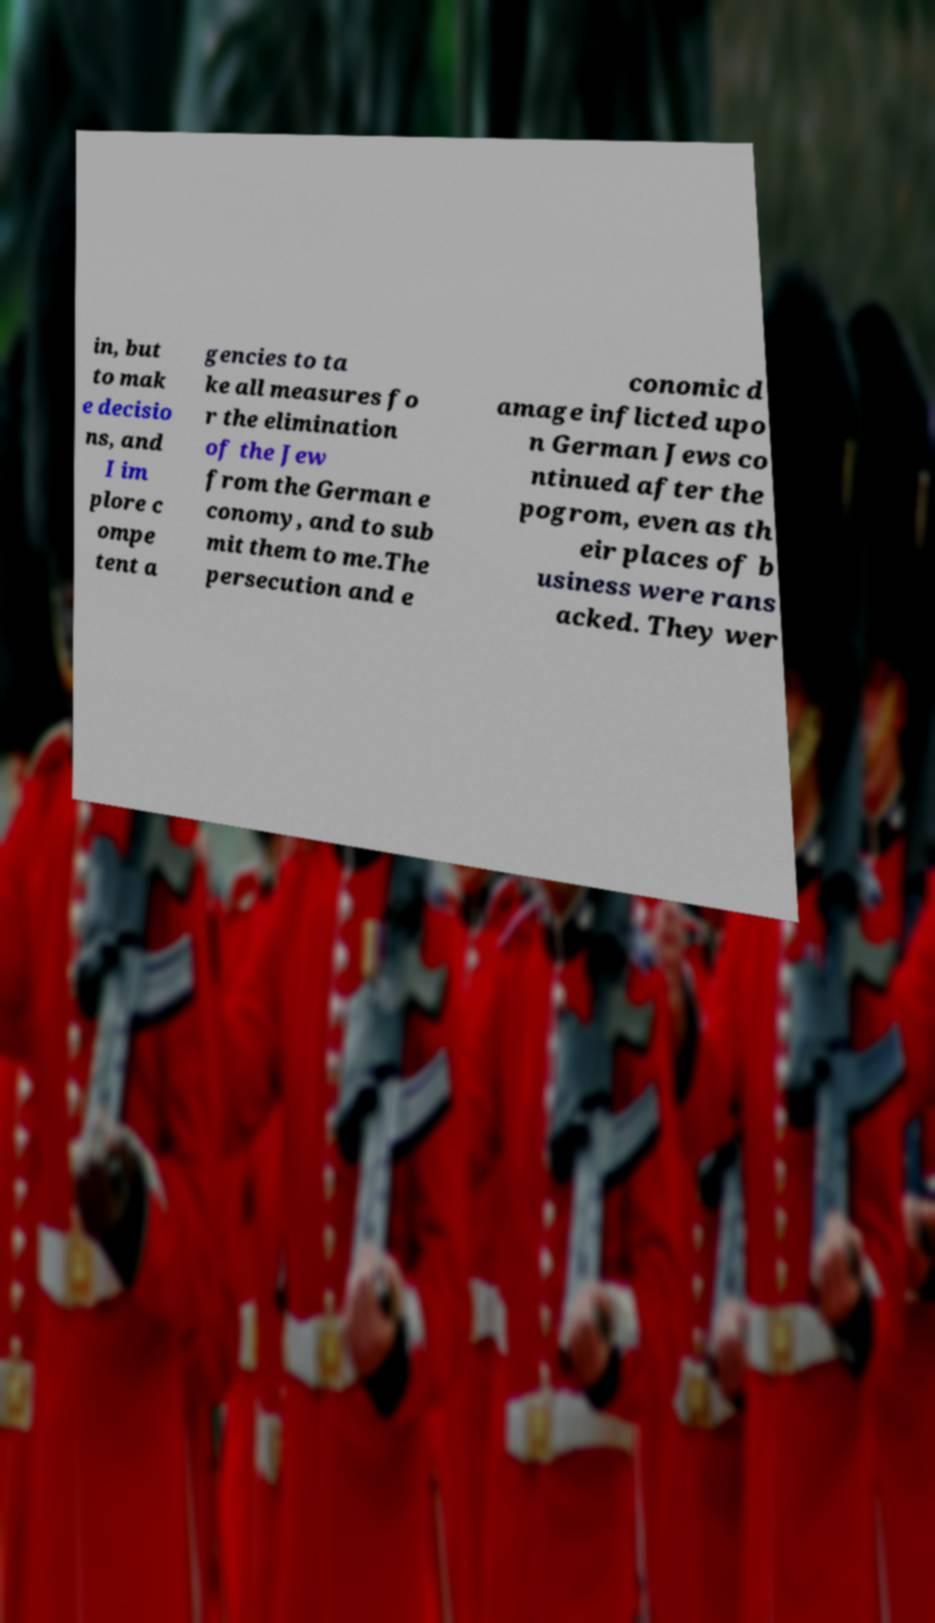I need the written content from this picture converted into text. Can you do that? in, but to mak e decisio ns, and I im plore c ompe tent a gencies to ta ke all measures fo r the elimination of the Jew from the German e conomy, and to sub mit them to me.The persecution and e conomic d amage inflicted upo n German Jews co ntinued after the pogrom, even as th eir places of b usiness were rans acked. They wer 